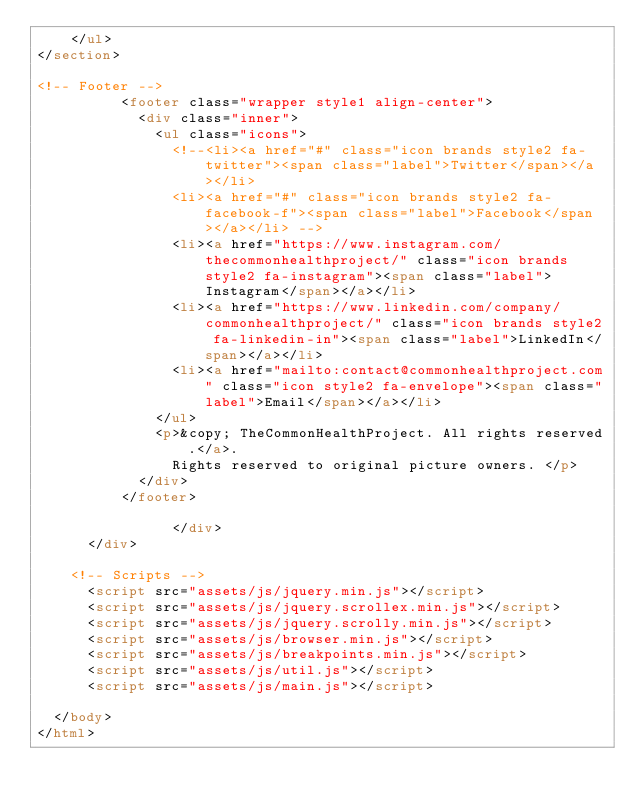Convert code to text. <code><loc_0><loc_0><loc_500><loc_500><_HTML_>    </ul>
</section>

<!-- Footer -->
					<footer class="wrapper style1 align-center">
						<div class="inner">
							<ul class="icons">
								<!--<li><a href="#" class="icon brands style2 fa-twitter"><span class="label">Twitter</span></a></li>
								<li><a href="#" class="icon brands style2 fa-facebook-f"><span class="label">Facebook</span></a></li> -->
								<li><a href="https://www.instagram.com/thecommonhealthproject/" class="icon brands style2 fa-instagram"><span class="label">Instagram</span></a></li>
								<li><a href="https://www.linkedin.com/company/commonhealthproject/" class="icon brands style2 fa-linkedin-in"><span class="label">LinkedIn</span></a></li>
								<li><a href="mailto:contact@commonhealthproject.com" class="icon style2 fa-envelope"><span class="label">Email</span></a></li>
							</ul>
							<p>&copy; TheCommonHealthProject. All rights reserved.</a>. 
								Rights reserved to original picture owners. </p>
						</div>
					</footer>
                    
                </div>
			</div>

		<!-- Scripts -->
			<script src="assets/js/jquery.min.js"></script>
			<script src="assets/js/jquery.scrollex.min.js"></script>
			<script src="assets/js/jquery.scrolly.min.js"></script>
			<script src="assets/js/browser.min.js"></script>
			<script src="assets/js/breakpoints.min.js"></script>
			<script src="assets/js/util.js"></script>
			<script src="assets/js/main.js"></script>

	</body>
</html></code> 